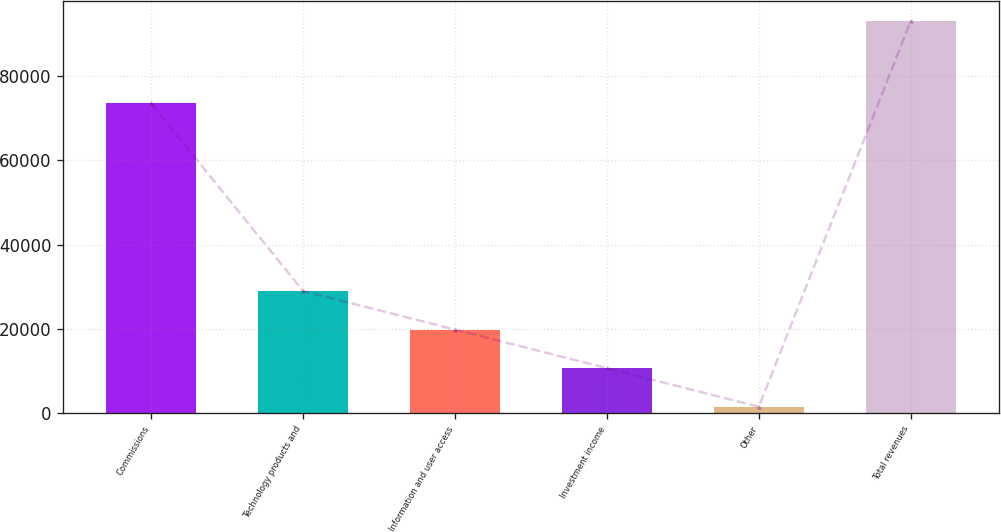<chart> <loc_0><loc_0><loc_500><loc_500><bar_chart><fcel>Commissions<fcel>Technology products and<fcel>Information and user access<fcel>Investment income<fcel>Other<fcel>Total revenues<nl><fcel>73528<fcel>28974.8<fcel>19816.2<fcel>10657.6<fcel>1499<fcel>93085<nl></chart> 